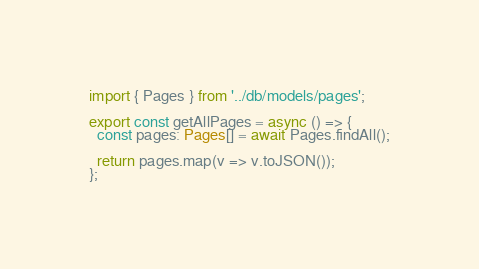<code> <loc_0><loc_0><loc_500><loc_500><_TypeScript_>import { Pages } from '../db/models/pages';

export const getAllPages = async () => {
  const pages: Pages[] = await Pages.findAll();

  return pages.map(v => v.toJSON());
};
</code> 